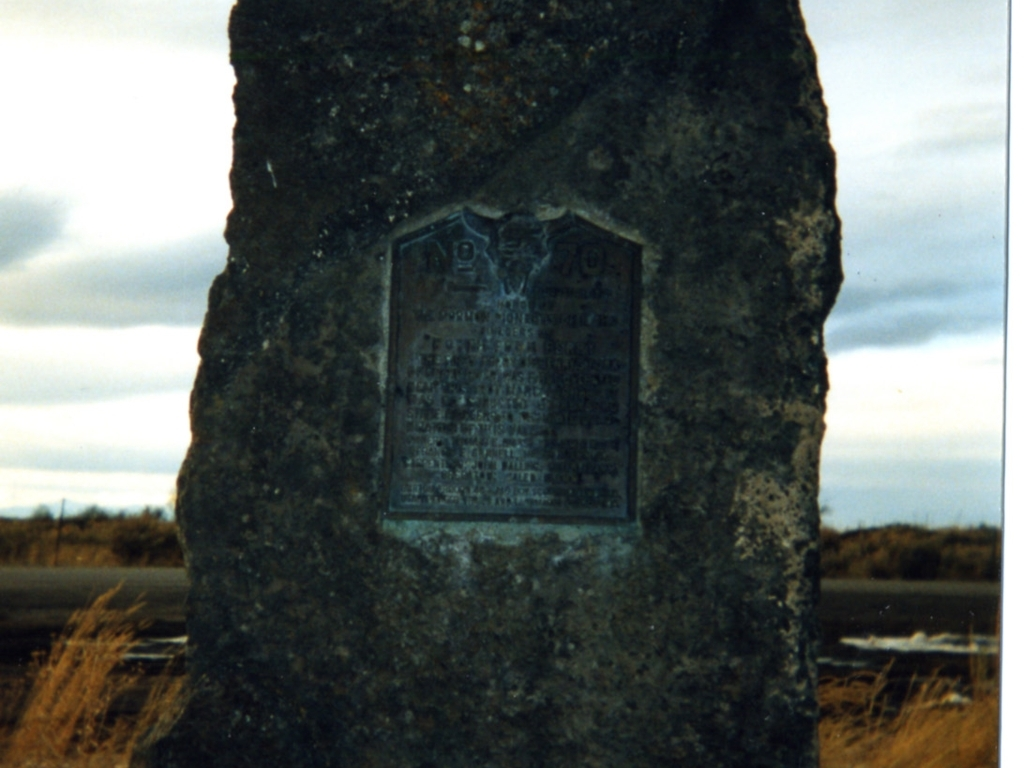Can you tell me more about what this monument might signify? This image shows a stone monument with a plaque. While the specific details are not clear due to the image quality, such monuments typically commemorate historical events or figures. The presence of written text suggests that there is significant information to be shared, likely regarding the history or significance of the location where this monument stands. 